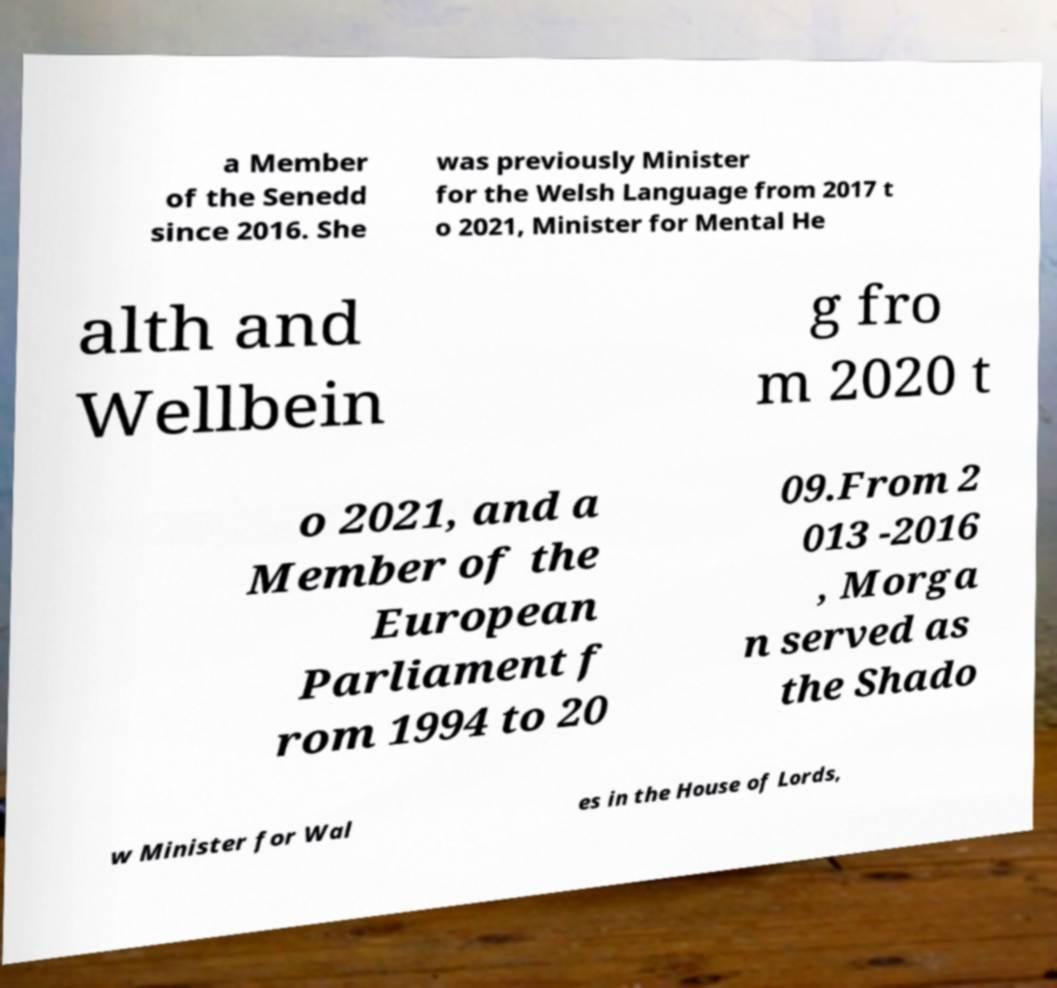Could you extract and type out the text from this image? a Member of the Senedd since 2016. She was previously Minister for the Welsh Language from 2017 t o 2021, Minister for Mental He alth and Wellbein g fro m 2020 t o 2021, and a Member of the European Parliament f rom 1994 to 20 09.From 2 013 -2016 , Morga n served as the Shado w Minister for Wal es in the House of Lords, 